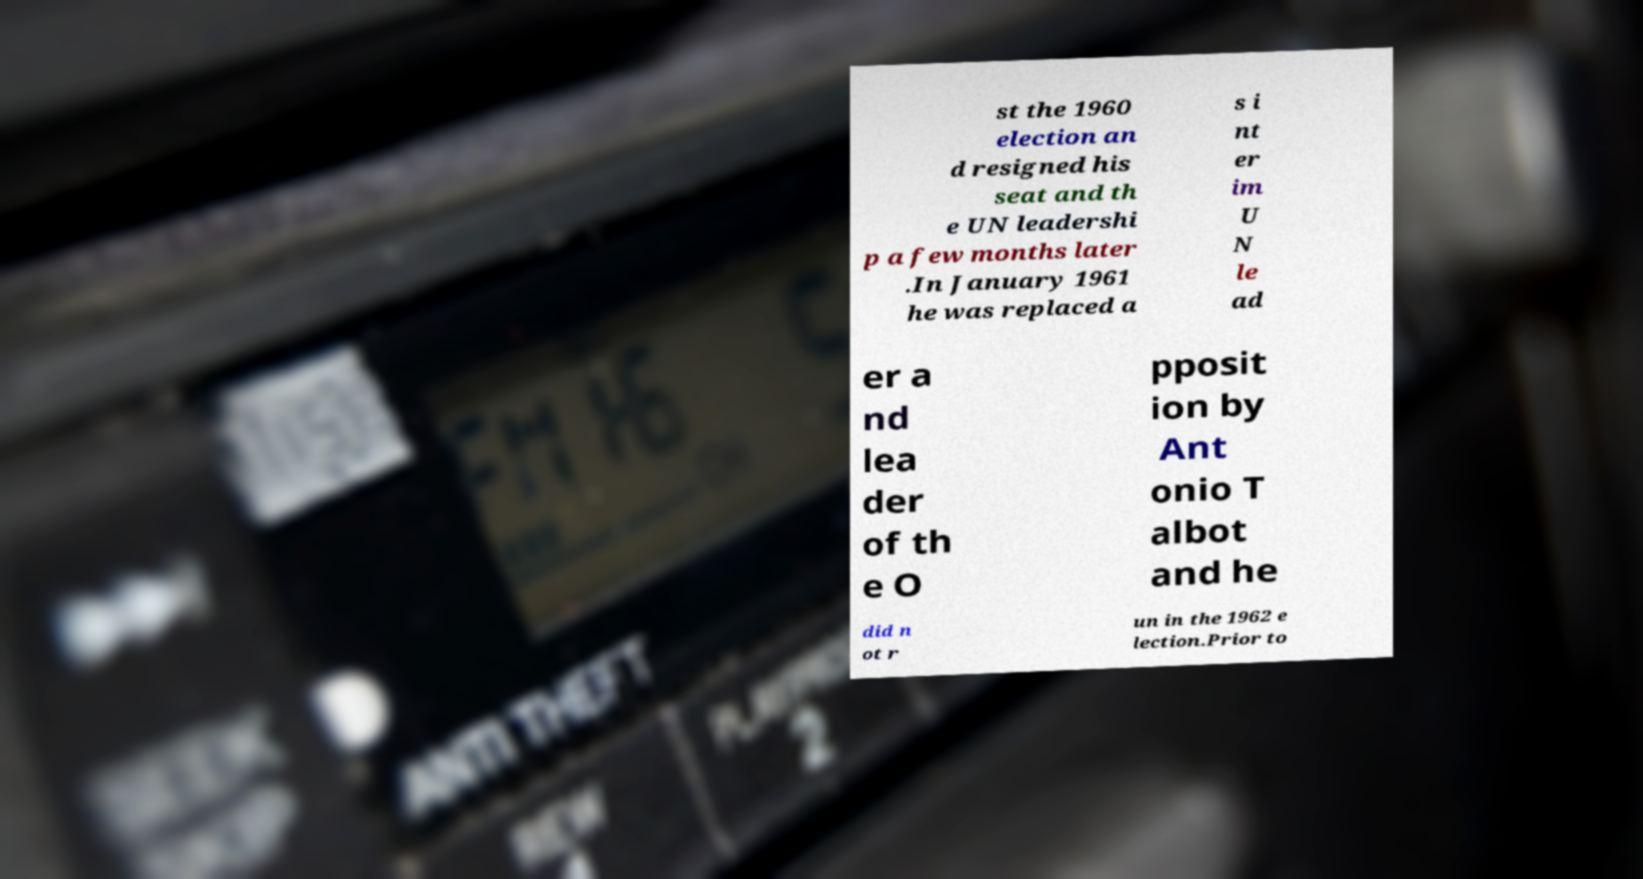Could you assist in decoding the text presented in this image and type it out clearly? st the 1960 election an d resigned his seat and th e UN leadershi p a few months later .In January 1961 he was replaced a s i nt er im U N le ad er a nd lea der of th e O pposit ion by Ant onio T albot and he did n ot r un in the 1962 e lection.Prior to 